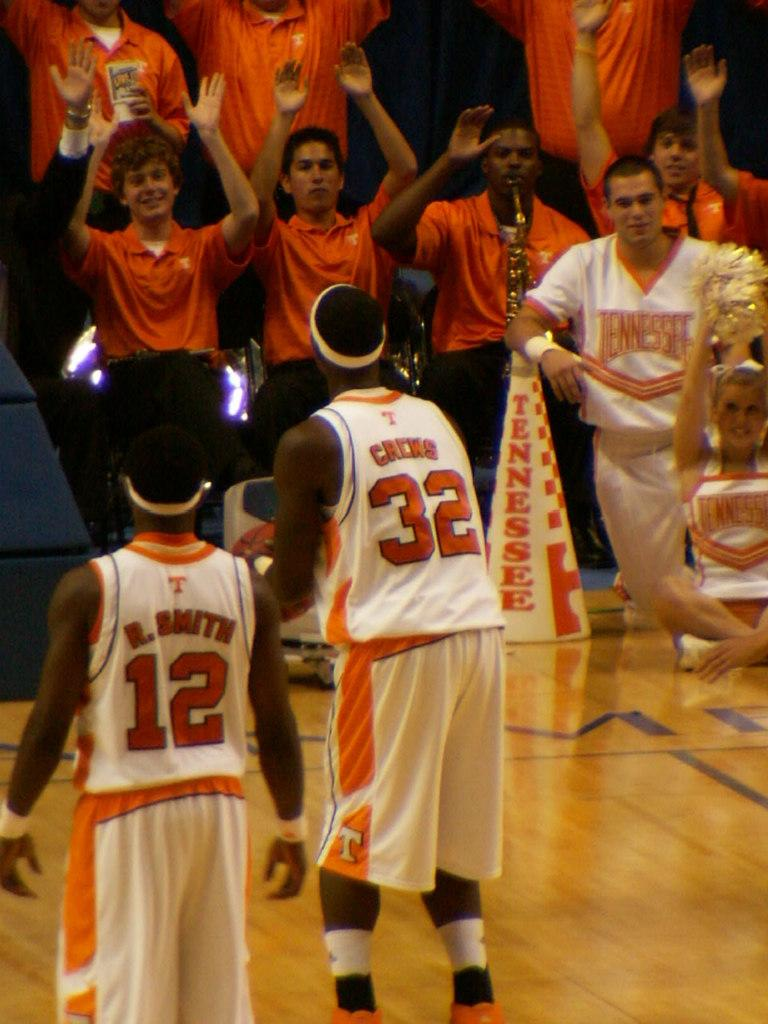<image>
Relay a brief, clear account of the picture shown. Basketball players wearing jersery number 12 and 32 face the crowd. 